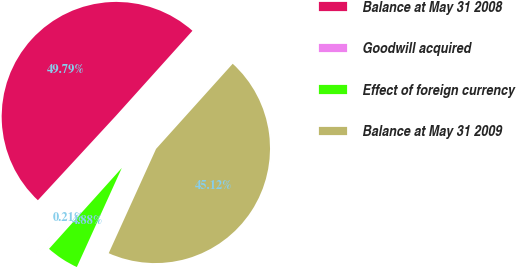Convert chart. <chart><loc_0><loc_0><loc_500><loc_500><pie_chart><fcel>Balance at May 31 2008<fcel>Goodwill acquired<fcel>Effect of foreign currency<fcel>Balance at May 31 2009<nl><fcel>49.79%<fcel>0.21%<fcel>4.88%<fcel>45.12%<nl></chart> 